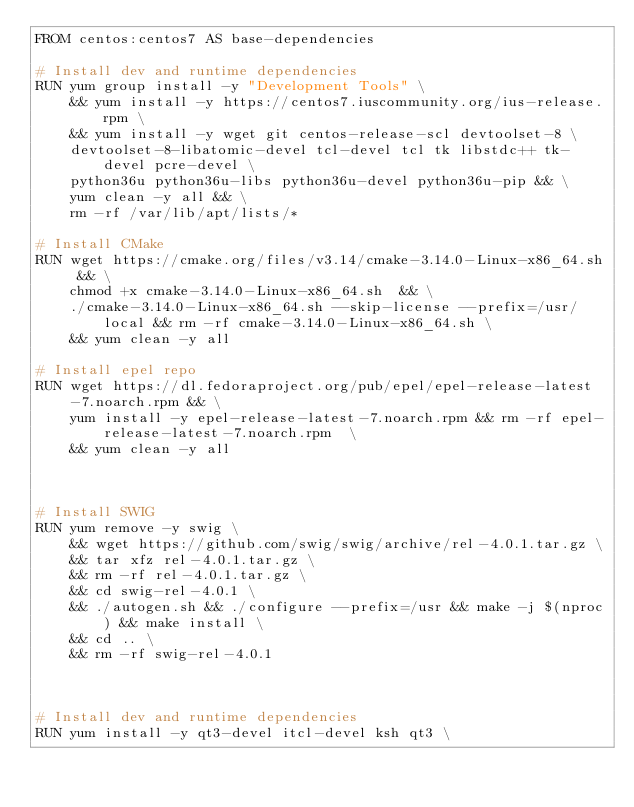Convert code to text. <code><loc_0><loc_0><loc_500><loc_500><_Dockerfile_>FROM centos:centos7 AS base-dependencies

# Install dev and runtime dependencies
RUN yum group install -y "Development Tools" \
    && yum install -y https://centos7.iuscommunity.org/ius-release.rpm \
    && yum install -y wget git centos-release-scl devtoolset-8 \
    devtoolset-8-libatomic-devel tcl-devel tcl tk libstdc++ tk-devel pcre-devel \
    python36u python36u-libs python36u-devel python36u-pip && \
    yum clean -y all && \
    rm -rf /var/lib/apt/lists/*

# Install CMake
RUN wget https://cmake.org/files/v3.14/cmake-3.14.0-Linux-x86_64.sh && \
    chmod +x cmake-3.14.0-Linux-x86_64.sh  && \
    ./cmake-3.14.0-Linux-x86_64.sh --skip-license --prefix=/usr/local && rm -rf cmake-3.14.0-Linux-x86_64.sh \
    && yum clean -y all

# Install epel repo
RUN wget https://dl.fedoraproject.org/pub/epel/epel-release-latest-7.noarch.rpm && \
    yum install -y epel-release-latest-7.noarch.rpm && rm -rf epel-release-latest-7.noarch.rpm  \
    && yum clean -y all



# Install SWIG
RUN yum remove -y swig \
    && wget https://github.com/swig/swig/archive/rel-4.0.1.tar.gz \
    && tar xfz rel-4.0.1.tar.gz \
    && rm -rf rel-4.0.1.tar.gz \
    && cd swig-rel-4.0.1 \
    && ./autogen.sh && ./configure --prefix=/usr && make -j $(nproc) && make install \
    && cd .. \
    && rm -rf swig-rel-4.0.1



# Install dev and runtime dependencies
RUN yum install -y qt3-devel itcl-devel ksh qt3 \</code> 